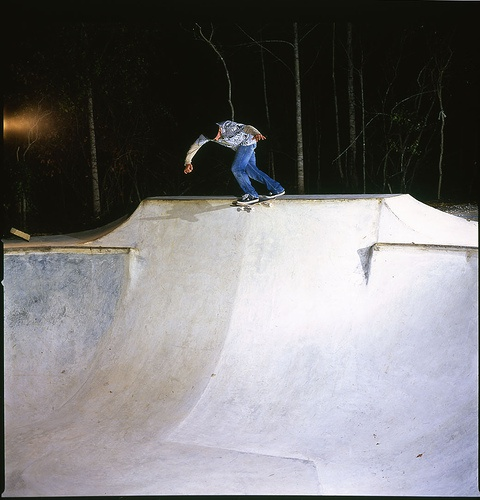Describe the objects in this image and their specific colors. I can see people in black, gray, and blue tones and skateboard in black, gray, lightgray, and darkgray tones in this image. 